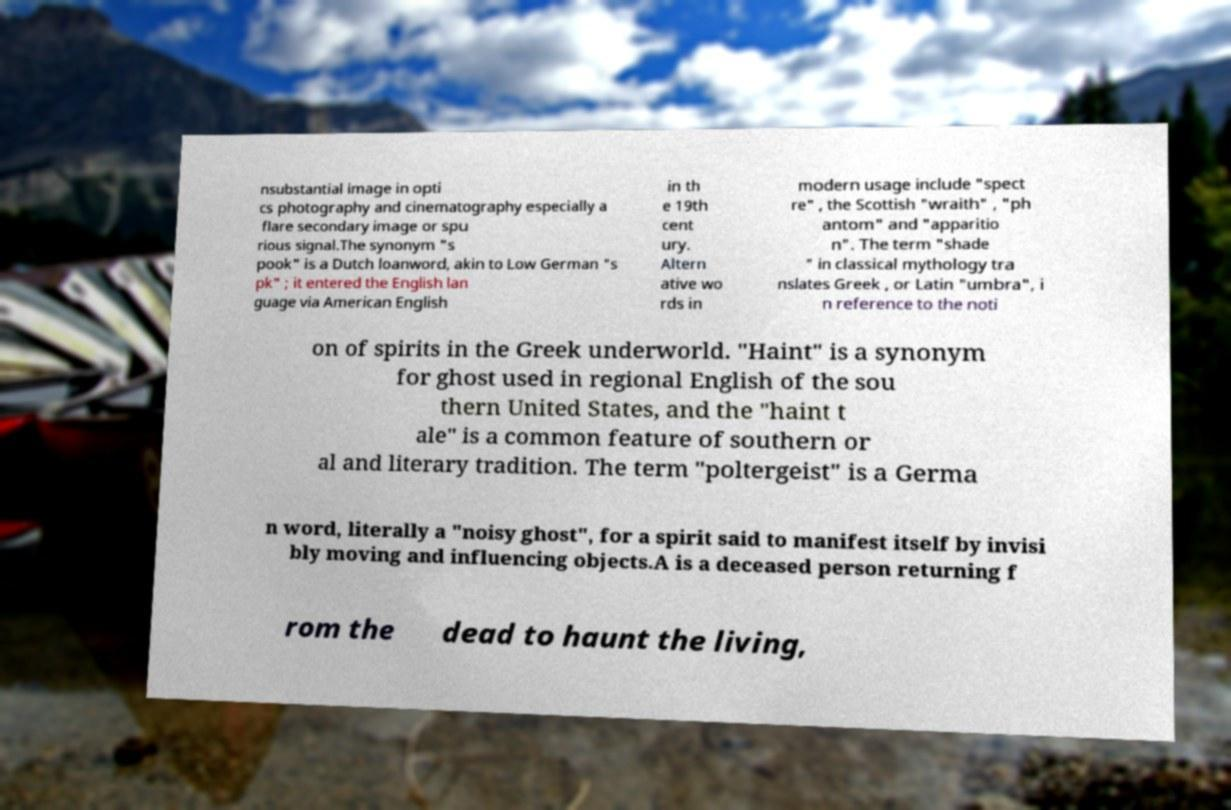There's text embedded in this image that I need extracted. Can you transcribe it verbatim? nsubstantial image in opti cs photography and cinematography especially a flare secondary image or spu rious signal.The synonym "s pook" is a Dutch loanword, akin to Low German "s pk" ; it entered the English lan guage via American English in th e 19th cent ury. Altern ative wo rds in modern usage include "spect re" , the Scottish "wraith" , "ph antom" and "apparitio n". The term "shade " in classical mythology tra nslates Greek , or Latin "umbra", i n reference to the noti on of spirits in the Greek underworld. "Haint" is a synonym for ghost used in regional English of the sou thern United States, and the "haint t ale" is a common feature of southern or al and literary tradition. The term "poltergeist" is a Germa n word, literally a "noisy ghost", for a spirit said to manifest itself by invisi bly moving and influencing objects.A is a deceased person returning f rom the dead to haunt the living, 